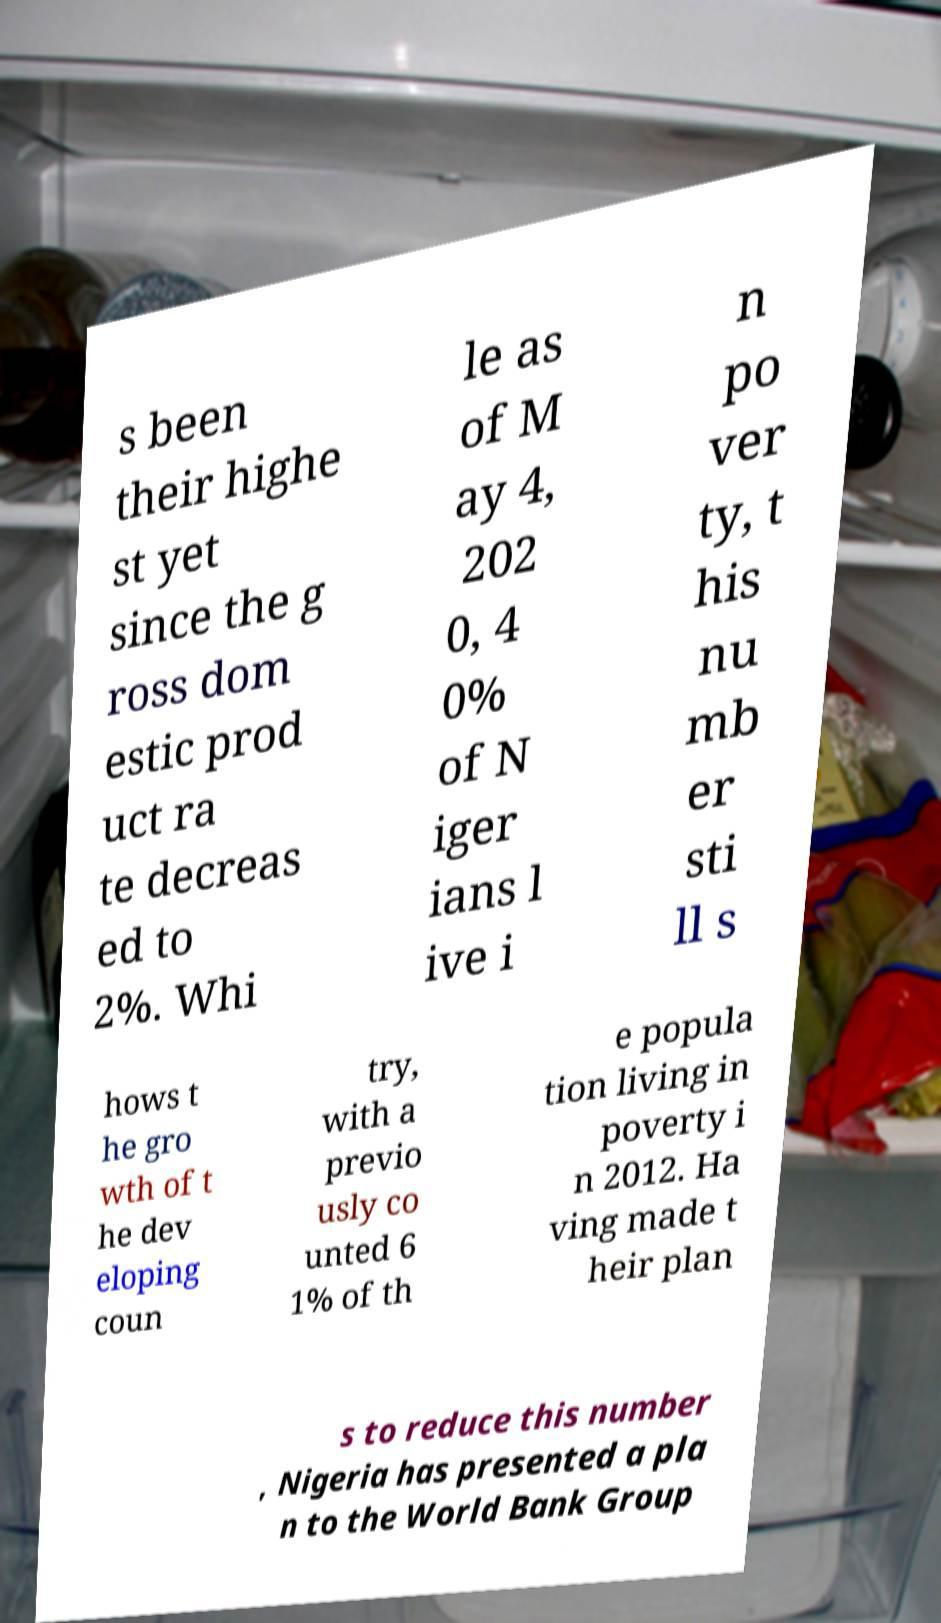Please read and relay the text visible in this image. What does it say? s been their highe st yet since the g ross dom estic prod uct ra te decreas ed to 2%. Whi le as of M ay 4, 202 0, 4 0% of N iger ians l ive i n po ver ty, t his nu mb er sti ll s hows t he gro wth of t he dev eloping coun try, with a previo usly co unted 6 1% of th e popula tion living in poverty i n 2012. Ha ving made t heir plan s to reduce this number , Nigeria has presented a pla n to the World Bank Group 